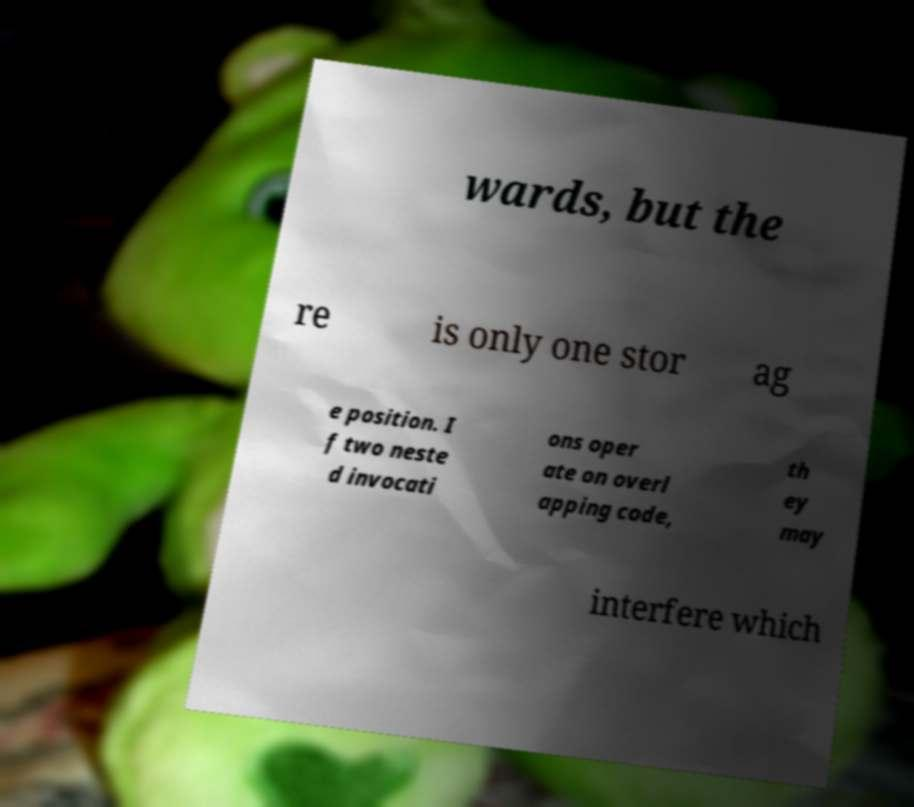There's text embedded in this image that I need extracted. Can you transcribe it verbatim? wards, but the re is only one stor ag e position. I f two neste d invocati ons oper ate on overl apping code, th ey may interfere which 